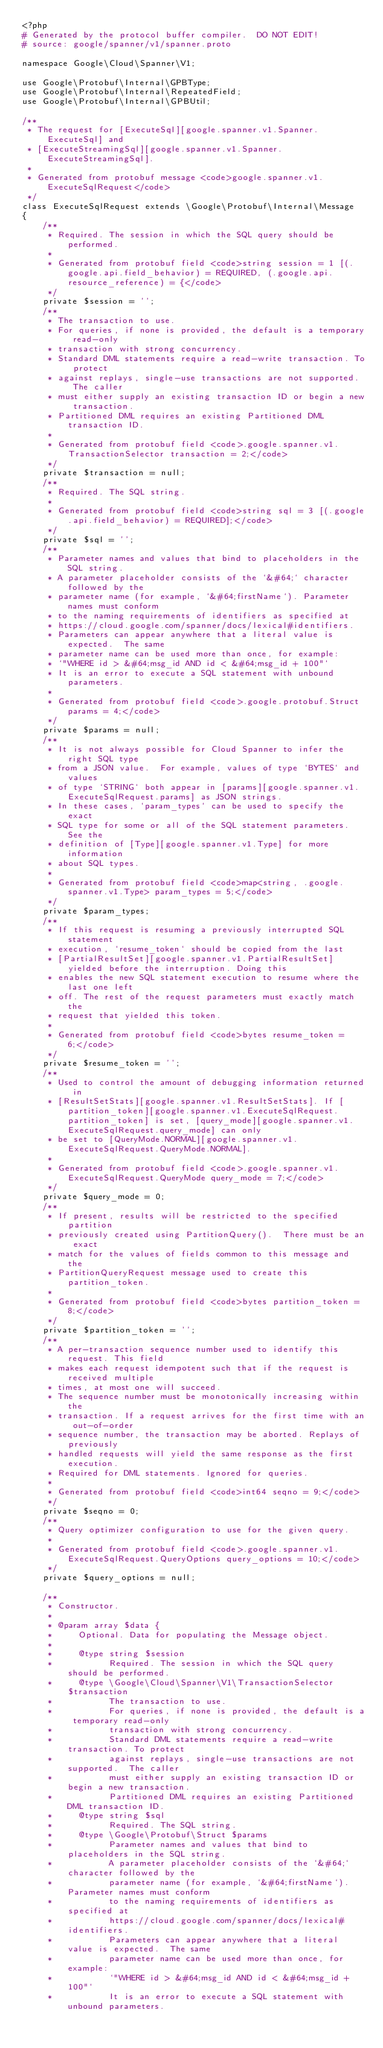Convert code to text. <code><loc_0><loc_0><loc_500><loc_500><_PHP_><?php
# Generated by the protocol buffer compiler.  DO NOT EDIT!
# source: google/spanner/v1/spanner.proto

namespace Google\Cloud\Spanner\V1;

use Google\Protobuf\Internal\GPBType;
use Google\Protobuf\Internal\RepeatedField;
use Google\Protobuf\Internal\GPBUtil;

/**
 * The request for [ExecuteSql][google.spanner.v1.Spanner.ExecuteSql] and
 * [ExecuteStreamingSql][google.spanner.v1.Spanner.ExecuteStreamingSql].
 *
 * Generated from protobuf message <code>google.spanner.v1.ExecuteSqlRequest</code>
 */
class ExecuteSqlRequest extends \Google\Protobuf\Internal\Message
{
    /**
     * Required. The session in which the SQL query should be performed.
     *
     * Generated from protobuf field <code>string session = 1 [(.google.api.field_behavior) = REQUIRED, (.google.api.resource_reference) = {</code>
     */
    private $session = '';
    /**
     * The transaction to use.
     * For queries, if none is provided, the default is a temporary read-only
     * transaction with strong concurrency.
     * Standard DML statements require a read-write transaction. To protect
     * against replays, single-use transactions are not supported.  The caller
     * must either supply an existing transaction ID or begin a new transaction.
     * Partitioned DML requires an existing Partitioned DML transaction ID.
     *
     * Generated from protobuf field <code>.google.spanner.v1.TransactionSelector transaction = 2;</code>
     */
    private $transaction = null;
    /**
     * Required. The SQL string.
     *
     * Generated from protobuf field <code>string sql = 3 [(.google.api.field_behavior) = REQUIRED];</code>
     */
    private $sql = '';
    /**
     * Parameter names and values that bind to placeholders in the SQL string.
     * A parameter placeholder consists of the `&#64;` character followed by the
     * parameter name (for example, `&#64;firstName`). Parameter names must conform
     * to the naming requirements of identifiers as specified at
     * https://cloud.google.com/spanner/docs/lexical#identifiers.
     * Parameters can appear anywhere that a literal value is expected.  The same
     * parameter name can be used more than once, for example:
     * `"WHERE id > &#64;msg_id AND id < &#64;msg_id + 100"`
     * It is an error to execute a SQL statement with unbound parameters.
     *
     * Generated from protobuf field <code>.google.protobuf.Struct params = 4;</code>
     */
    private $params = null;
    /**
     * It is not always possible for Cloud Spanner to infer the right SQL type
     * from a JSON value.  For example, values of type `BYTES` and values
     * of type `STRING` both appear in [params][google.spanner.v1.ExecuteSqlRequest.params] as JSON strings.
     * In these cases, `param_types` can be used to specify the exact
     * SQL type for some or all of the SQL statement parameters. See the
     * definition of [Type][google.spanner.v1.Type] for more information
     * about SQL types.
     *
     * Generated from protobuf field <code>map<string, .google.spanner.v1.Type> param_types = 5;</code>
     */
    private $param_types;
    /**
     * If this request is resuming a previously interrupted SQL statement
     * execution, `resume_token` should be copied from the last
     * [PartialResultSet][google.spanner.v1.PartialResultSet] yielded before the interruption. Doing this
     * enables the new SQL statement execution to resume where the last one left
     * off. The rest of the request parameters must exactly match the
     * request that yielded this token.
     *
     * Generated from protobuf field <code>bytes resume_token = 6;</code>
     */
    private $resume_token = '';
    /**
     * Used to control the amount of debugging information returned in
     * [ResultSetStats][google.spanner.v1.ResultSetStats]. If [partition_token][google.spanner.v1.ExecuteSqlRequest.partition_token] is set, [query_mode][google.spanner.v1.ExecuteSqlRequest.query_mode] can only
     * be set to [QueryMode.NORMAL][google.spanner.v1.ExecuteSqlRequest.QueryMode.NORMAL].
     *
     * Generated from protobuf field <code>.google.spanner.v1.ExecuteSqlRequest.QueryMode query_mode = 7;</code>
     */
    private $query_mode = 0;
    /**
     * If present, results will be restricted to the specified partition
     * previously created using PartitionQuery().  There must be an exact
     * match for the values of fields common to this message and the
     * PartitionQueryRequest message used to create this partition_token.
     *
     * Generated from protobuf field <code>bytes partition_token = 8;</code>
     */
    private $partition_token = '';
    /**
     * A per-transaction sequence number used to identify this request. This field
     * makes each request idempotent such that if the request is received multiple
     * times, at most one will succeed.
     * The sequence number must be monotonically increasing within the
     * transaction. If a request arrives for the first time with an out-of-order
     * sequence number, the transaction may be aborted. Replays of previously
     * handled requests will yield the same response as the first execution.
     * Required for DML statements. Ignored for queries.
     *
     * Generated from protobuf field <code>int64 seqno = 9;</code>
     */
    private $seqno = 0;
    /**
     * Query optimizer configuration to use for the given query.
     *
     * Generated from protobuf field <code>.google.spanner.v1.ExecuteSqlRequest.QueryOptions query_options = 10;</code>
     */
    private $query_options = null;

    /**
     * Constructor.
     *
     * @param array $data {
     *     Optional. Data for populating the Message object.
     *
     *     @type string $session
     *           Required. The session in which the SQL query should be performed.
     *     @type \Google\Cloud\Spanner\V1\TransactionSelector $transaction
     *           The transaction to use.
     *           For queries, if none is provided, the default is a temporary read-only
     *           transaction with strong concurrency.
     *           Standard DML statements require a read-write transaction. To protect
     *           against replays, single-use transactions are not supported.  The caller
     *           must either supply an existing transaction ID or begin a new transaction.
     *           Partitioned DML requires an existing Partitioned DML transaction ID.
     *     @type string $sql
     *           Required. The SQL string.
     *     @type \Google\Protobuf\Struct $params
     *           Parameter names and values that bind to placeholders in the SQL string.
     *           A parameter placeholder consists of the `&#64;` character followed by the
     *           parameter name (for example, `&#64;firstName`). Parameter names must conform
     *           to the naming requirements of identifiers as specified at
     *           https://cloud.google.com/spanner/docs/lexical#identifiers.
     *           Parameters can appear anywhere that a literal value is expected.  The same
     *           parameter name can be used more than once, for example:
     *           `"WHERE id > &#64;msg_id AND id < &#64;msg_id + 100"`
     *           It is an error to execute a SQL statement with unbound parameters.</code> 